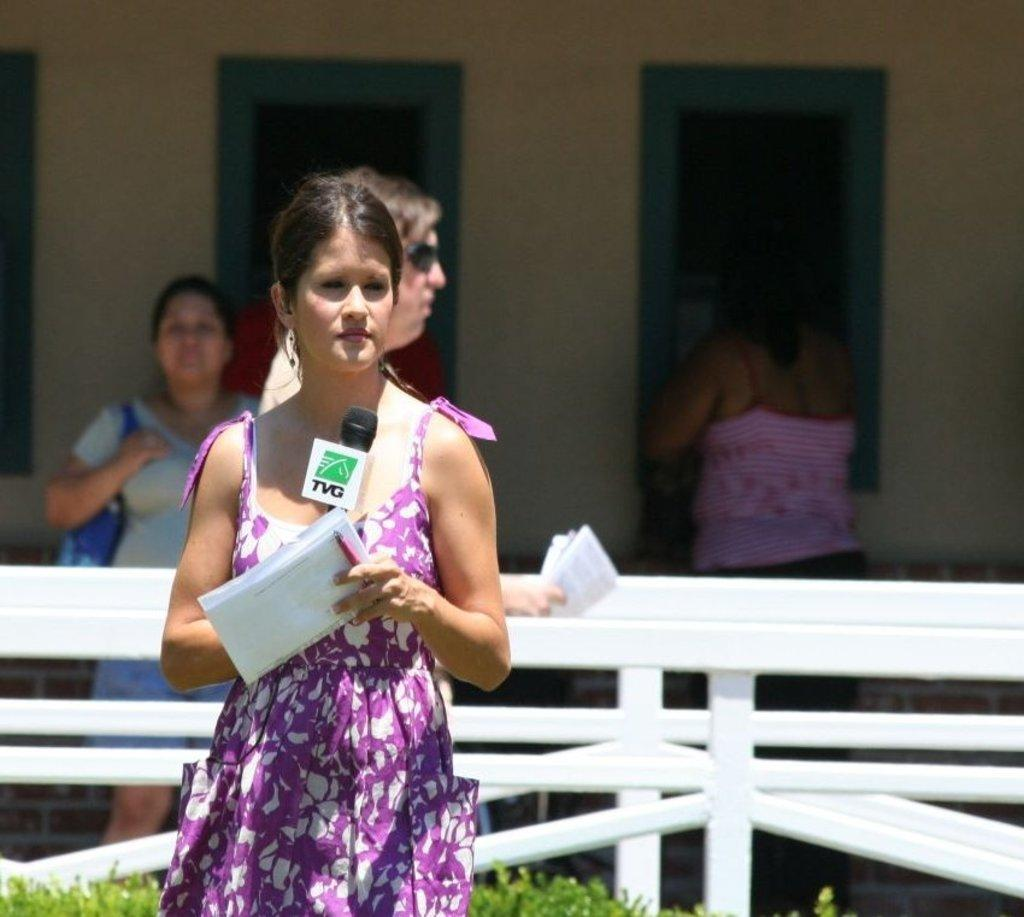What is the person in the image holding? The person is holding papers, a pen, and a microphone. What might the person be doing with the pen and papers? The person might be writing or taking notes with the pen and papers. How many people are visible in the image? There are at least two people visible in the image, as one person is holding a microphone and there are other people standing nearby. What is the purpose of the microphone? The microphone might be used for amplifying the person's voice during a presentation or speech. What can be seen in the background of the image? There is a wall with windows in the background of the image. What type of food is the person eating in the image? There is no food present in the image; the person is holding papers, a pen, and a microphone. What is the person's elbow doing in the image? The person's elbow is not mentioned in the image, as the focus is on the items they are holding. 